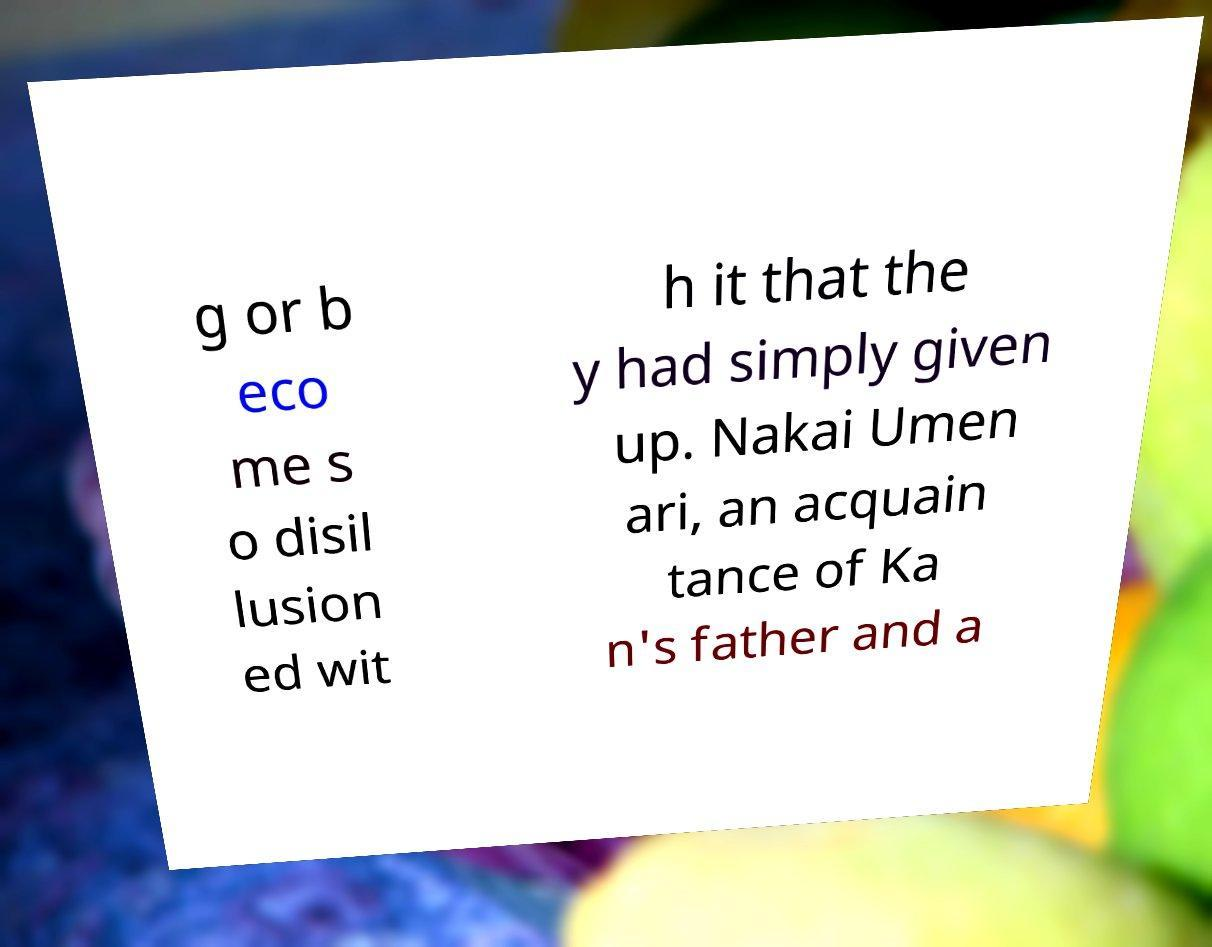Please identify and transcribe the text found in this image. g or b eco me s o disil lusion ed wit h it that the y had simply given up. Nakai Umen ari, an acquain tance of Ka n's father and a 